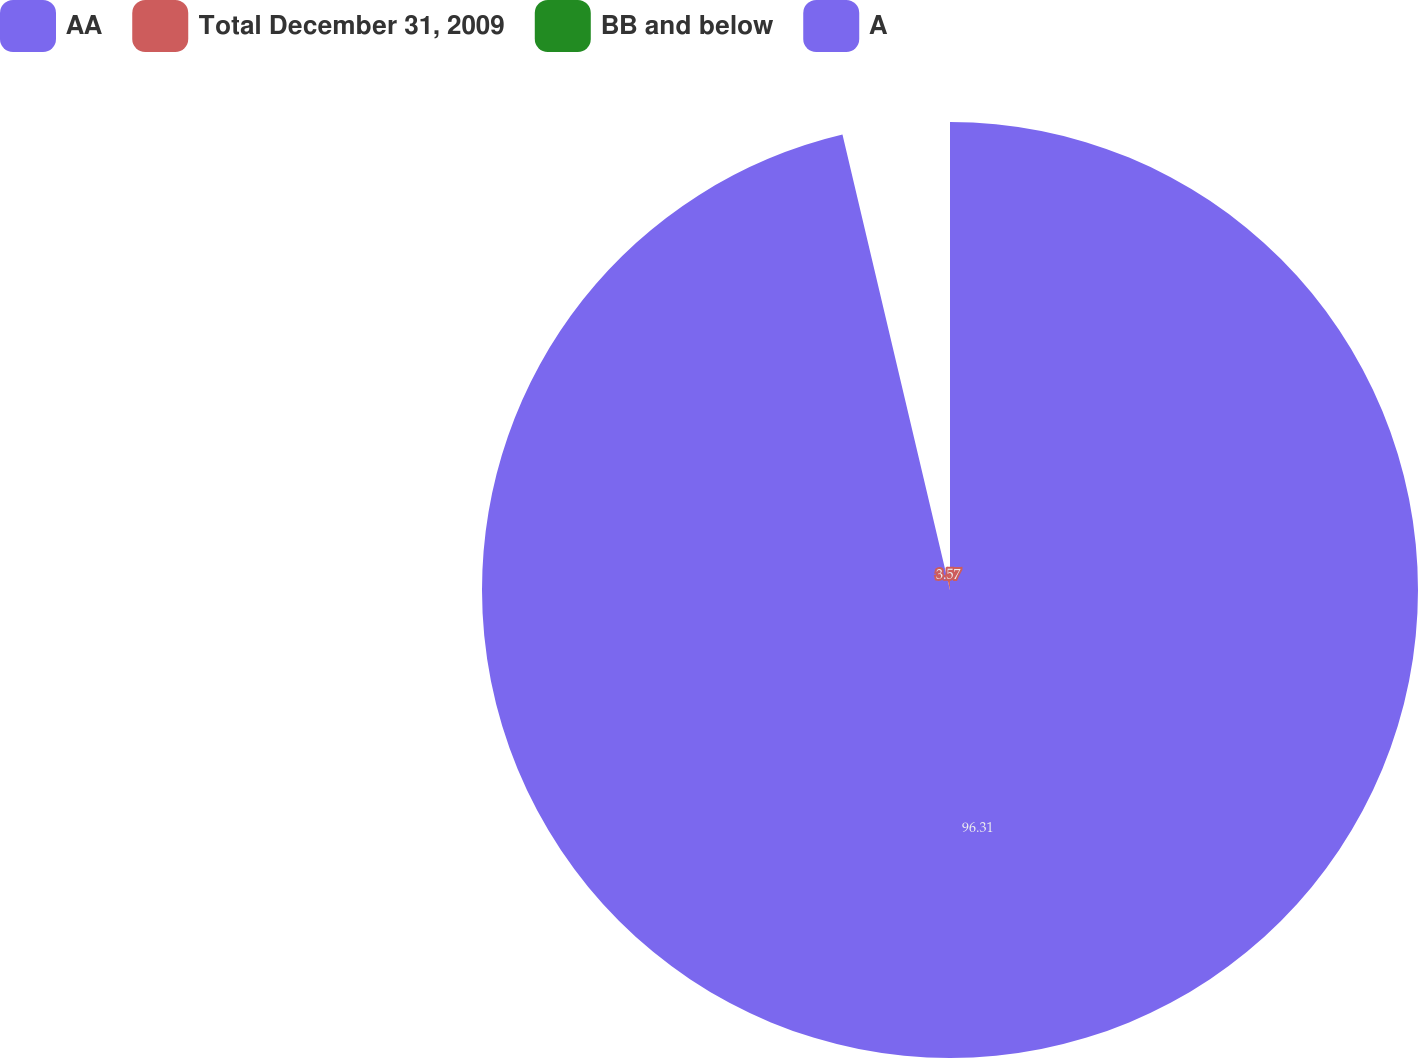Convert chart to OTSL. <chart><loc_0><loc_0><loc_500><loc_500><pie_chart><fcel>AA<fcel>Total December 31, 2009<fcel>BB and below<fcel>A<nl><fcel>96.31%<fcel>3.57%<fcel>0.06%<fcel>0.06%<nl></chart> 